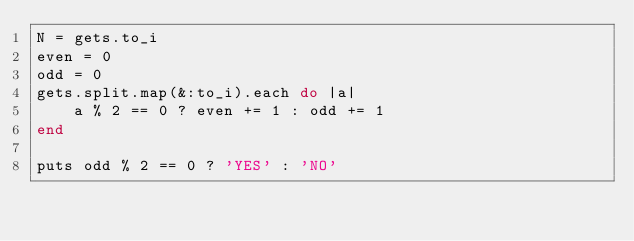<code> <loc_0><loc_0><loc_500><loc_500><_Ruby_>N = gets.to_i
even = 0
odd = 0
gets.split.map(&:to_i).each do |a|
    a % 2 == 0 ? even += 1 : odd += 1
end

puts odd % 2 == 0 ? 'YES' : 'NO'</code> 